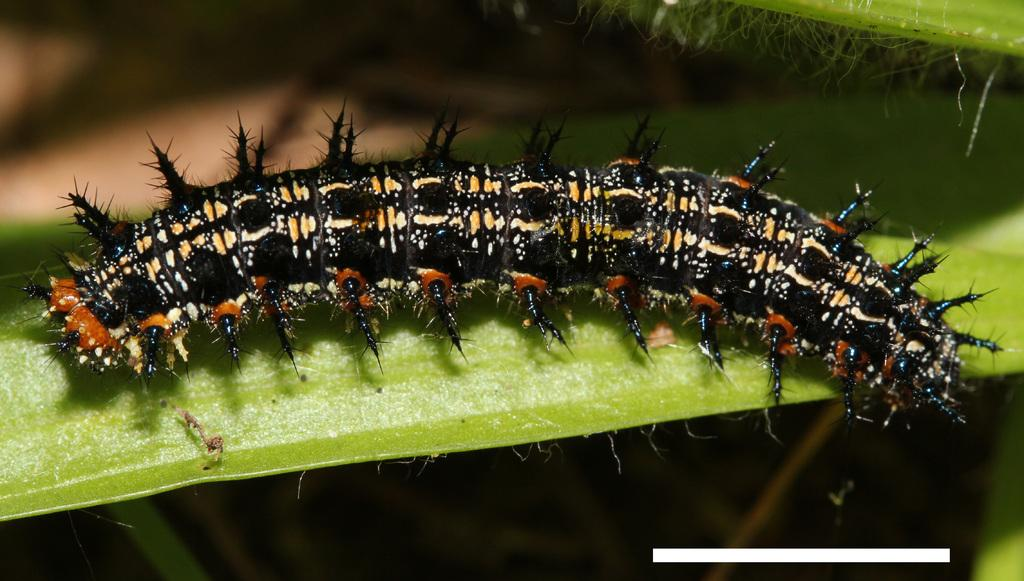What type of insect is in the image? There is a black color caterpillar in the image. Where is the caterpillar located? The caterpillar is on a leaf. Can you describe the background of the image? The background of the image is blurred. What type of stove is visible in the image? There is no stove present in the image. What relation does the caterpillar have with the leaf in the image? The caterpillar is on the leaf, but there is no indication of a specific relationship between them. 